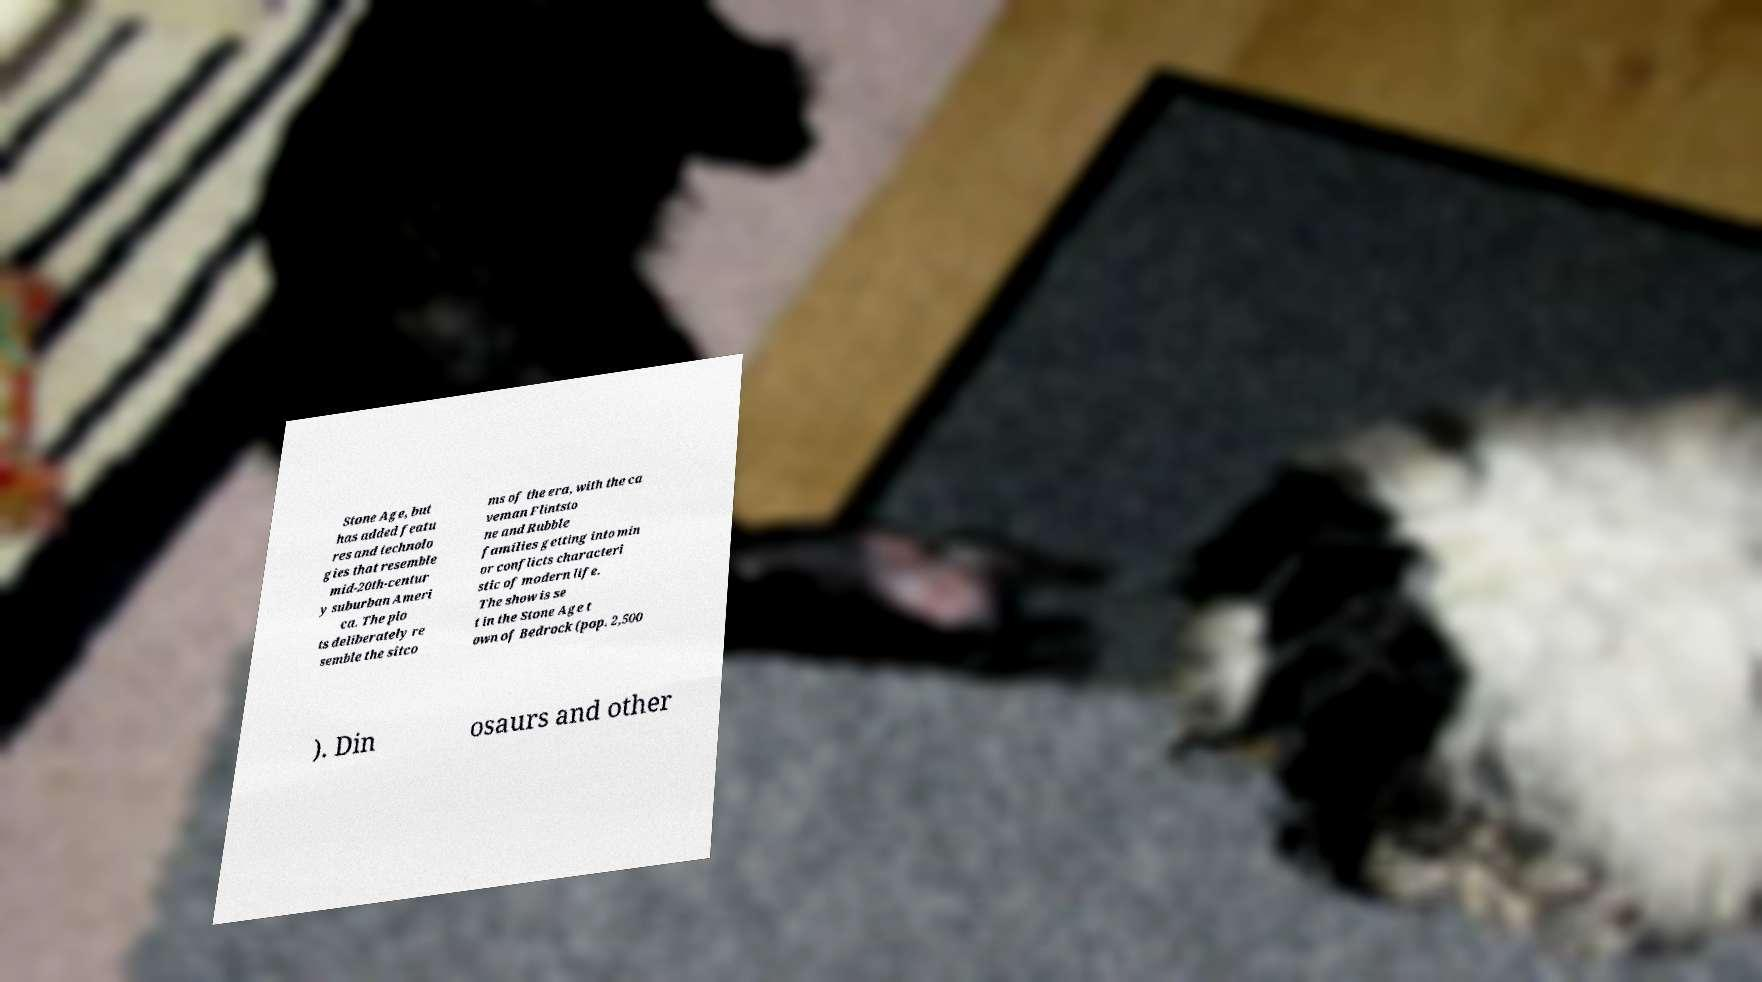There's text embedded in this image that I need extracted. Can you transcribe it verbatim? Stone Age, but has added featu res and technolo gies that resemble mid-20th-centur y suburban Ameri ca. The plo ts deliberately re semble the sitco ms of the era, with the ca veman Flintsto ne and Rubble families getting into min or conflicts characteri stic of modern life. The show is se t in the Stone Age t own of Bedrock (pop. 2,500 ). Din osaurs and other 